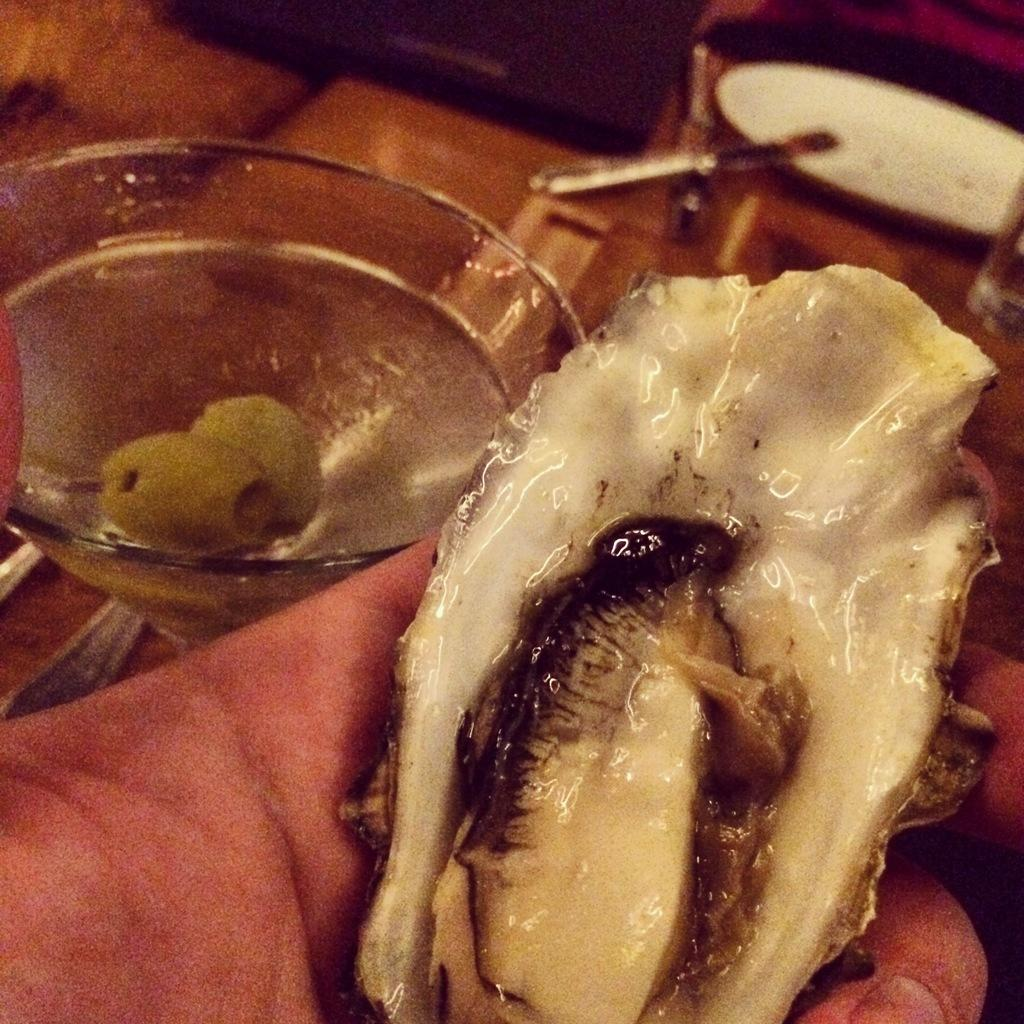What is on the person's hand in the image? There is food on a person's hand in the image. What type of container is visible in the image? There is a glass in the image. Can you describe the background of the image? There are objects in the background of the image. What type of minister is present in the image? There is no minister present in the image. How many pies are visible in the image? There is no mention of pies in the provided facts, so we cannot determine if any are present in the image. 